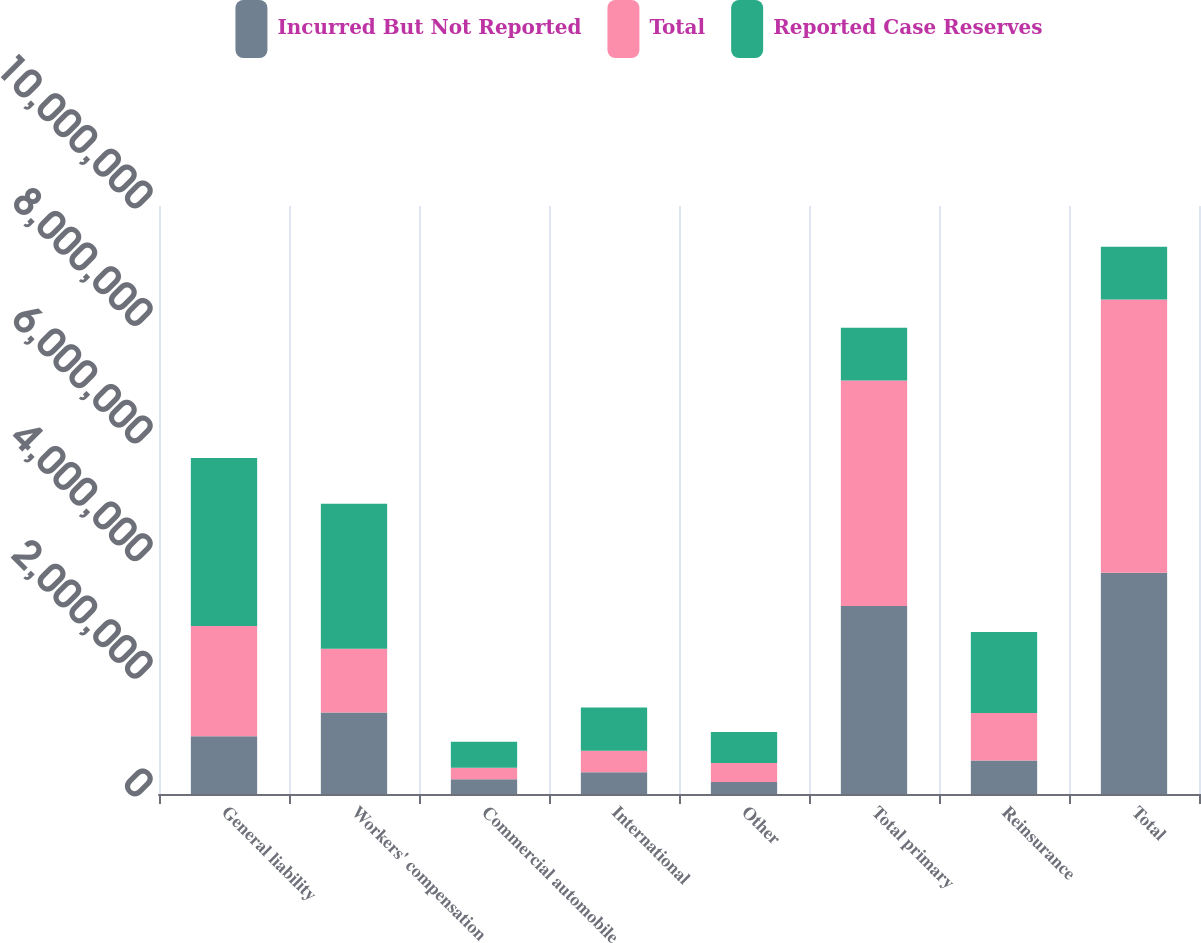<chart> <loc_0><loc_0><loc_500><loc_500><stacked_bar_chart><ecel><fcel>General liability<fcel>Workers' compensation<fcel>Commercial automobile<fcel>International<fcel>Other<fcel>Total primary<fcel>Reinsurance<fcel>Total<nl><fcel>Incurred But Not Reported<fcel>984206<fcel>1.38632e+06<fcel>252198<fcel>367803<fcel>205611<fcel>3.19614e+06<fcel>568576<fcel>3.76472e+06<nl><fcel>Total<fcel>1.87258e+06<fcel>1.08246e+06<fcel>192759<fcel>368656<fcel>321630<fcel>3.83809e+06<fcel>809043<fcel>4.64714e+06<nl><fcel>Reported Case Reserves<fcel>2.85679e+06<fcel>2.46878e+06<fcel>444957<fcel>736459<fcel>527241<fcel>896624<fcel>1.37762e+06<fcel>896624<nl></chart> 